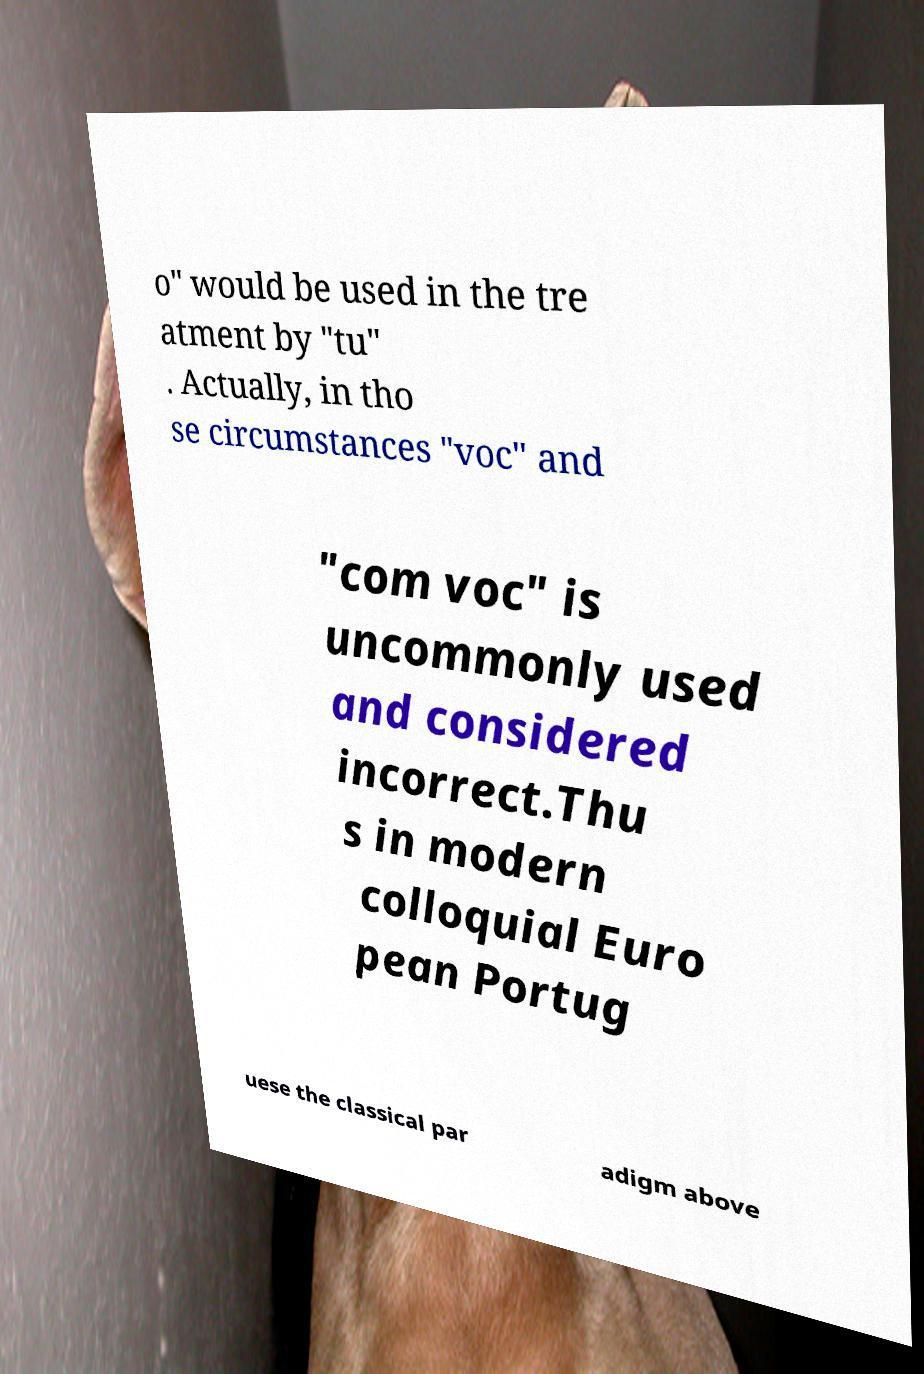What messages or text are displayed in this image? I need them in a readable, typed format. o" would be used in the tre atment by "tu" . Actually, in tho se circumstances "voc" and "com voc" is uncommonly used and considered incorrect.Thu s in modern colloquial Euro pean Portug uese the classical par adigm above 